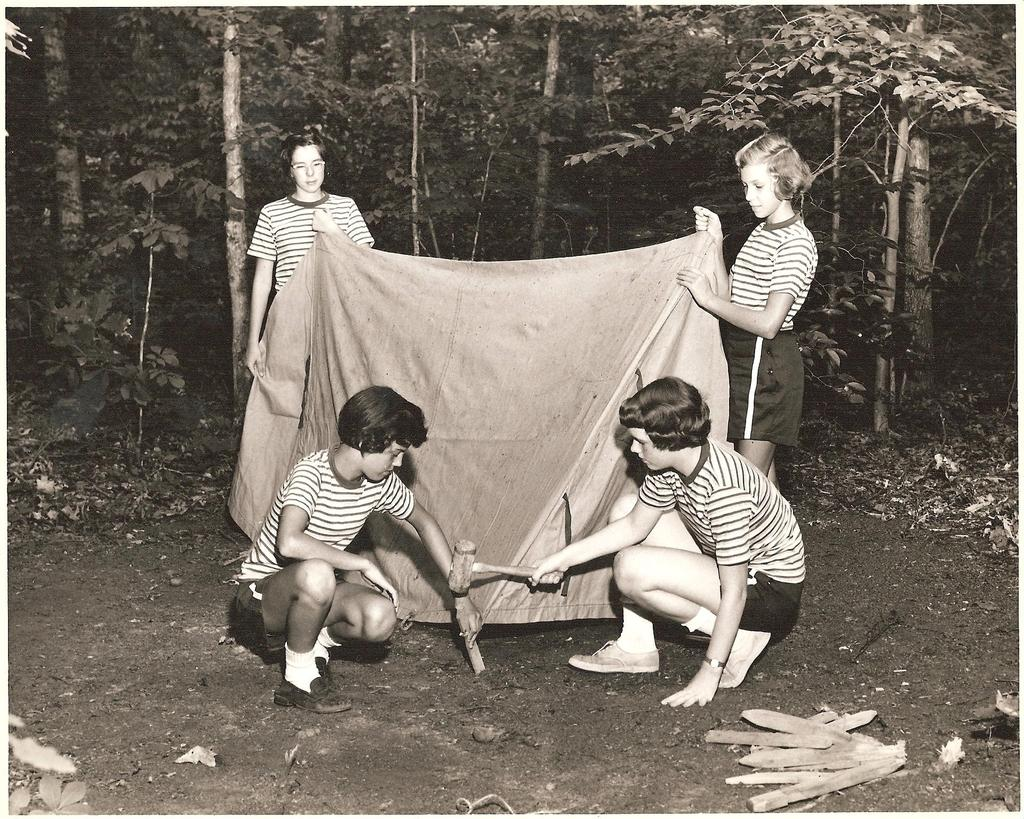What are the two people in the image holding together? The two people in the image are holding a hammer together. What else are the two people holding in the image? The two people are also holding a cloth in the image. What can be seen in the background of the image? There are trees visible in the background of the image. What type of owl can be seen perched on the hammer in the image? There is no owl present in the image; the two people are holding a hammer and a cloth. What is the visibility like in the image due to the presence of mist? There is no mention of mist in the image, so it cannot be determined if the visibility is affected by it. 